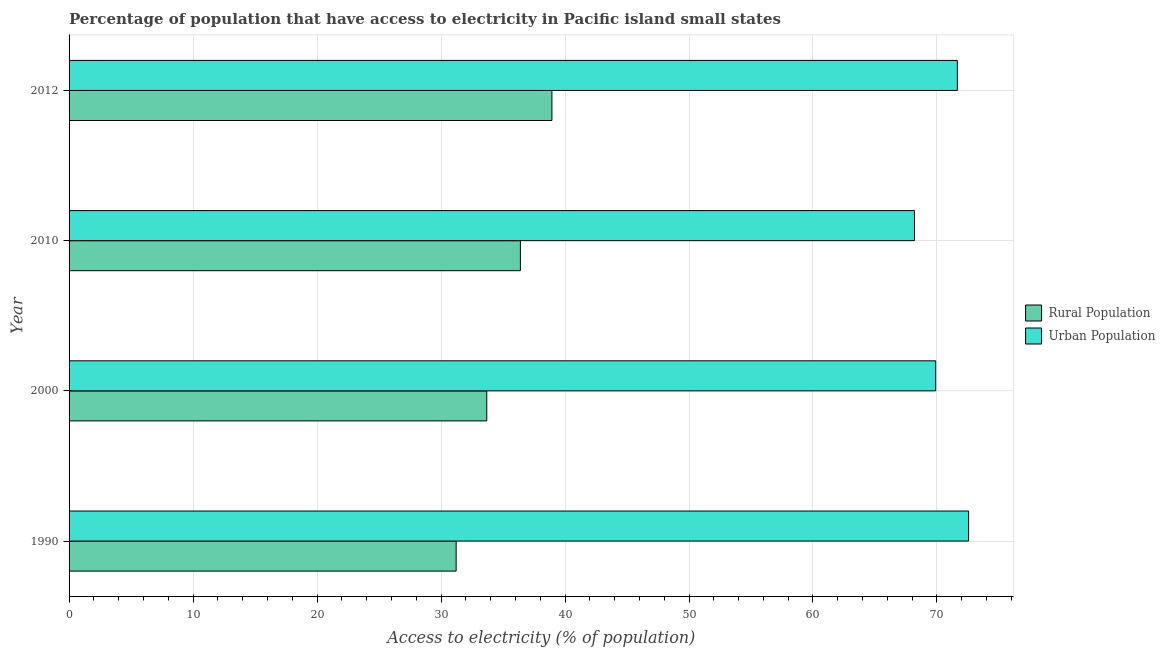How many groups of bars are there?
Ensure brevity in your answer.  4. Are the number of bars per tick equal to the number of legend labels?
Provide a short and direct response. Yes. What is the label of the 4th group of bars from the top?
Give a very brief answer. 1990. In how many cases, is the number of bars for a given year not equal to the number of legend labels?
Your response must be concise. 0. What is the percentage of urban population having access to electricity in 2000?
Offer a terse response. 69.89. Across all years, what is the maximum percentage of urban population having access to electricity?
Offer a very short reply. 72.55. Across all years, what is the minimum percentage of rural population having access to electricity?
Make the answer very short. 31.22. In which year was the percentage of rural population having access to electricity maximum?
Your answer should be compact. 2012. In which year was the percentage of urban population having access to electricity minimum?
Ensure brevity in your answer.  2010. What is the total percentage of urban population having access to electricity in the graph?
Give a very brief answer. 282.27. What is the difference between the percentage of rural population having access to electricity in 2000 and that in 2012?
Provide a short and direct response. -5.25. What is the difference between the percentage of urban population having access to electricity in 2012 and the percentage of rural population having access to electricity in 2010?
Ensure brevity in your answer.  35.24. What is the average percentage of rural population having access to electricity per year?
Provide a succinct answer. 35.06. In the year 2010, what is the difference between the percentage of rural population having access to electricity and percentage of urban population having access to electricity?
Ensure brevity in your answer.  -31.78. What is the ratio of the percentage of rural population having access to electricity in 1990 to that in 2000?
Make the answer very short. 0.93. Is the difference between the percentage of rural population having access to electricity in 1990 and 2010 greater than the difference between the percentage of urban population having access to electricity in 1990 and 2010?
Your answer should be very brief. No. What is the difference between the highest and the second highest percentage of urban population having access to electricity?
Offer a terse response. 0.91. What is the difference between the highest and the lowest percentage of urban population having access to electricity?
Give a very brief answer. 4.37. Is the sum of the percentage of rural population having access to electricity in 1990 and 2012 greater than the maximum percentage of urban population having access to electricity across all years?
Give a very brief answer. No. What does the 1st bar from the top in 1990 represents?
Keep it short and to the point. Urban Population. What does the 1st bar from the bottom in 2010 represents?
Your answer should be very brief. Rural Population. Are all the bars in the graph horizontal?
Make the answer very short. Yes. Does the graph contain any zero values?
Give a very brief answer. No. Does the graph contain grids?
Provide a short and direct response. Yes. How many legend labels are there?
Provide a succinct answer. 2. What is the title of the graph?
Provide a succinct answer. Percentage of population that have access to electricity in Pacific island small states. Does "Investment" appear as one of the legend labels in the graph?
Keep it short and to the point. No. What is the label or title of the X-axis?
Your response must be concise. Access to electricity (% of population). What is the Access to electricity (% of population) of Rural Population in 1990?
Your response must be concise. 31.22. What is the Access to electricity (% of population) of Urban Population in 1990?
Offer a terse response. 72.55. What is the Access to electricity (% of population) in Rural Population in 2000?
Your answer should be very brief. 33.69. What is the Access to electricity (% of population) of Urban Population in 2000?
Offer a terse response. 69.89. What is the Access to electricity (% of population) in Rural Population in 2010?
Give a very brief answer. 36.4. What is the Access to electricity (% of population) in Urban Population in 2010?
Give a very brief answer. 68.18. What is the Access to electricity (% of population) in Rural Population in 2012?
Your answer should be very brief. 38.94. What is the Access to electricity (% of population) in Urban Population in 2012?
Your response must be concise. 71.64. Across all years, what is the maximum Access to electricity (% of population) of Rural Population?
Offer a terse response. 38.94. Across all years, what is the maximum Access to electricity (% of population) of Urban Population?
Make the answer very short. 72.55. Across all years, what is the minimum Access to electricity (% of population) in Rural Population?
Your answer should be very brief. 31.22. Across all years, what is the minimum Access to electricity (% of population) in Urban Population?
Your answer should be compact. 68.18. What is the total Access to electricity (% of population) of Rural Population in the graph?
Offer a terse response. 140.25. What is the total Access to electricity (% of population) of Urban Population in the graph?
Ensure brevity in your answer.  282.27. What is the difference between the Access to electricity (% of population) of Rural Population in 1990 and that in 2000?
Your response must be concise. -2.47. What is the difference between the Access to electricity (% of population) of Urban Population in 1990 and that in 2000?
Your response must be concise. 2.66. What is the difference between the Access to electricity (% of population) of Rural Population in 1990 and that in 2010?
Ensure brevity in your answer.  -5.18. What is the difference between the Access to electricity (% of population) in Urban Population in 1990 and that in 2010?
Ensure brevity in your answer.  4.37. What is the difference between the Access to electricity (% of population) in Rural Population in 1990 and that in 2012?
Ensure brevity in your answer.  -7.73. What is the difference between the Access to electricity (% of population) of Urban Population in 1990 and that in 2012?
Provide a short and direct response. 0.91. What is the difference between the Access to electricity (% of population) in Rural Population in 2000 and that in 2010?
Provide a short and direct response. -2.71. What is the difference between the Access to electricity (% of population) in Urban Population in 2000 and that in 2010?
Provide a short and direct response. 1.71. What is the difference between the Access to electricity (% of population) in Rural Population in 2000 and that in 2012?
Make the answer very short. -5.26. What is the difference between the Access to electricity (% of population) of Urban Population in 2000 and that in 2012?
Your response must be concise. -1.75. What is the difference between the Access to electricity (% of population) in Rural Population in 2010 and that in 2012?
Your answer should be compact. -2.54. What is the difference between the Access to electricity (% of population) of Urban Population in 2010 and that in 2012?
Ensure brevity in your answer.  -3.46. What is the difference between the Access to electricity (% of population) in Rural Population in 1990 and the Access to electricity (% of population) in Urban Population in 2000?
Your answer should be compact. -38.68. What is the difference between the Access to electricity (% of population) of Rural Population in 1990 and the Access to electricity (% of population) of Urban Population in 2010?
Give a very brief answer. -36.97. What is the difference between the Access to electricity (% of population) of Rural Population in 1990 and the Access to electricity (% of population) of Urban Population in 2012?
Offer a very short reply. -40.42. What is the difference between the Access to electricity (% of population) in Rural Population in 2000 and the Access to electricity (% of population) in Urban Population in 2010?
Offer a terse response. -34.5. What is the difference between the Access to electricity (% of population) of Rural Population in 2000 and the Access to electricity (% of population) of Urban Population in 2012?
Your response must be concise. -37.95. What is the difference between the Access to electricity (% of population) of Rural Population in 2010 and the Access to electricity (% of population) of Urban Population in 2012?
Make the answer very short. -35.24. What is the average Access to electricity (% of population) of Rural Population per year?
Keep it short and to the point. 35.06. What is the average Access to electricity (% of population) in Urban Population per year?
Provide a short and direct response. 70.57. In the year 1990, what is the difference between the Access to electricity (% of population) of Rural Population and Access to electricity (% of population) of Urban Population?
Provide a succinct answer. -41.33. In the year 2000, what is the difference between the Access to electricity (% of population) in Rural Population and Access to electricity (% of population) in Urban Population?
Provide a short and direct response. -36.21. In the year 2010, what is the difference between the Access to electricity (% of population) of Rural Population and Access to electricity (% of population) of Urban Population?
Keep it short and to the point. -31.78. In the year 2012, what is the difference between the Access to electricity (% of population) in Rural Population and Access to electricity (% of population) in Urban Population?
Provide a short and direct response. -32.7. What is the ratio of the Access to electricity (% of population) of Rural Population in 1990 to that in 2000?
Your answer should be compact. 0.93. What is the ratio of the Access to electricity (% of population) in Urban Population in 1990 to that in 2000?
Your answer should be very brief. 1.04. What is the ratio of the Access to electricity (% of population) in Rural Population in 1990 to that in 2010?
Your response must be concise. 0.86. What is the ratio of the Access to electricity (% of population) in Urban Population in 1990 to that in 2010?
Give a very brief answer. 1.06. What is the ratio of the Access to electricity (% of population) in Rural Population in 1990 to that in 2012?
Give a very brief answer. 0.8. What is the ratio of the Access to electricity (% of population) of Urban Population in 1990 to that in 2012?
Your response must be concise. 1.01. What is the ratio of the Access to electricity (% of population) in Rural Population in 2000 to that in 2010?
Ensure brevity in your answer.  0.93. What is the ratio of the Access to electricity (% of population) of Urban Population in 2000 to that in 2010?
Ensure brevity in your answer.  1.03. What is the ratio of the Access to electricity (% of population) of Rural Population in 2000 to that in 2012?
Your answer should be very brief. 0.87. What is the ratio of the Access to electricity (% of population) in Urban Population in 2000 to that in 2012?
Your response must be concise. 0.98. What is the ratio of the Access to electricity (% of population) in Rural Population in 2010 to that in 2012?
Offer a terse response. 0.93. What is the ratio of the Access to electricity (% of population) in Urban Population in 2010 to that in 2012?
Offer a terse response. 0.95. What is the difference between the highest and the second highest Access to electricity (% of population) of Rural Population?
Offer a terse response. 2.54. What is the difference between the highest and the second highest Access to electricity (% of population) of Urban Population?
Your answer should be compact. 0.91. What is the difference between the highest and the lowest Access to electricity (% of population) of Rural Population?
Your answer should be very brief. 7.73. What is the difference between the highest and the lowest Access to electricity (% of population) of Urban Population?
Your response must be concise. 4.37. 